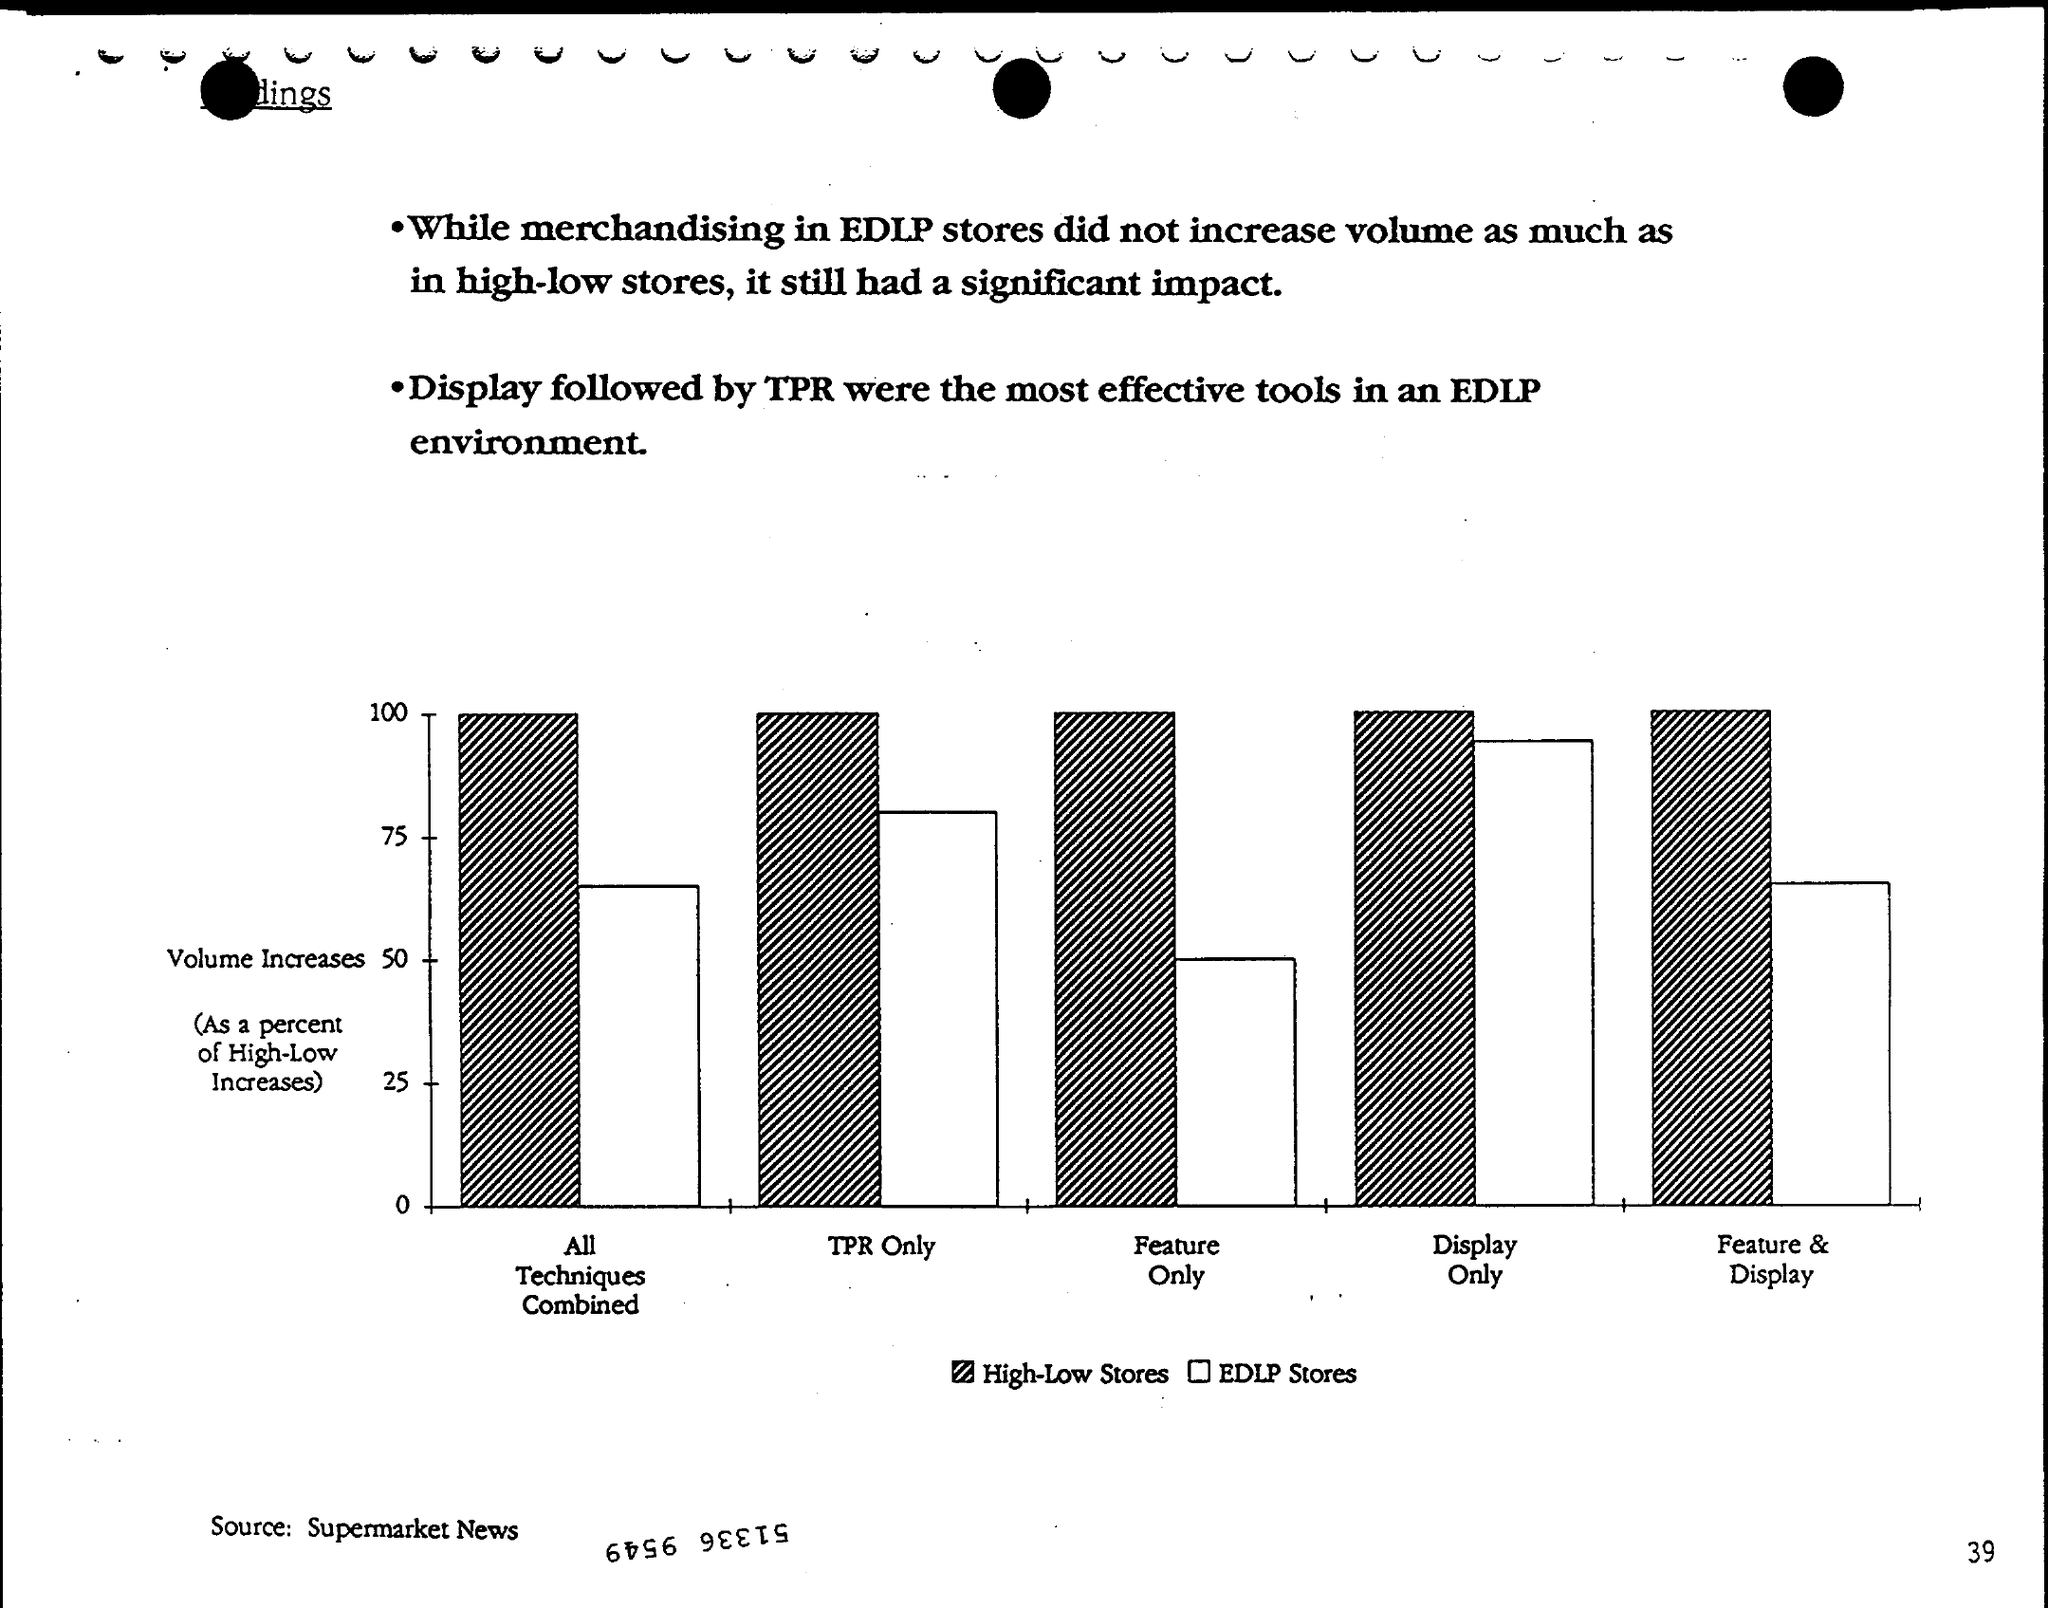Who is the Source?
Your response must be concise. Supermarket News. What is the Page Number?
Make the answer very short. 39. 